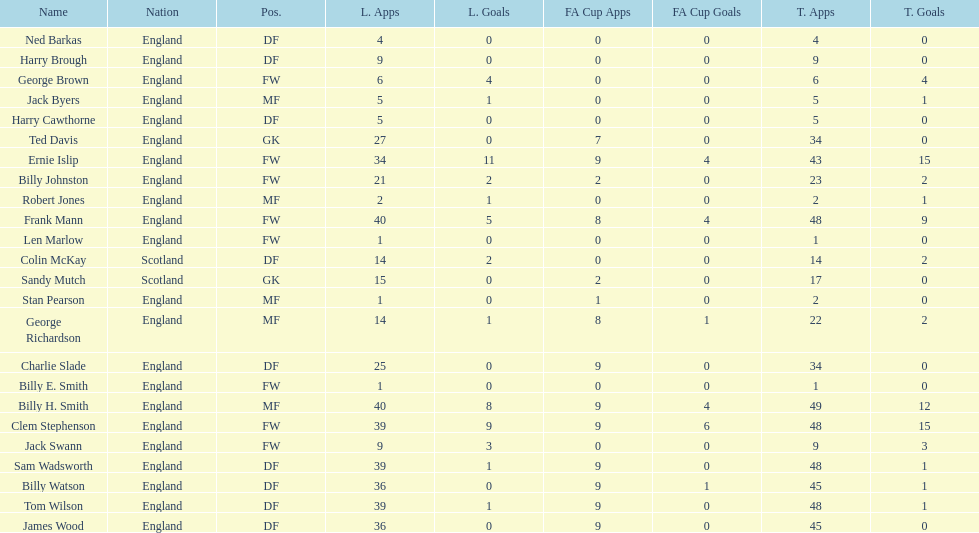The minimum amount of total occurrences 1. 